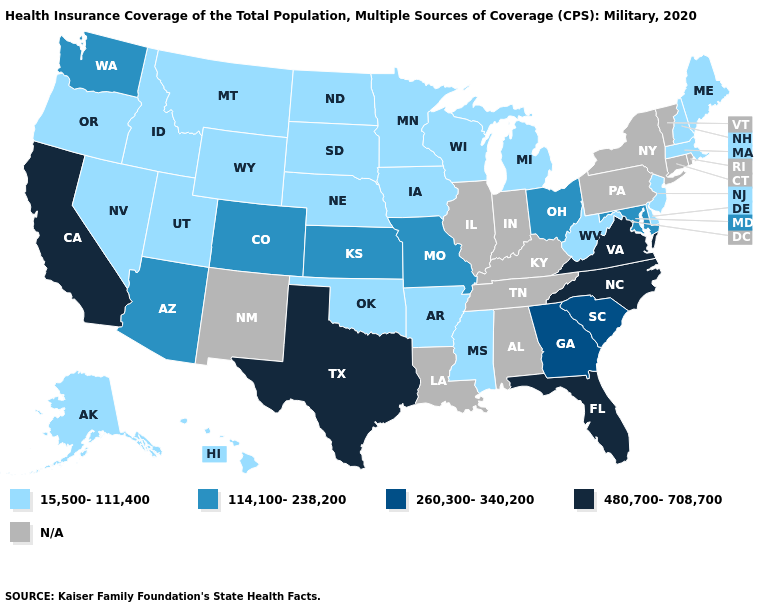Name the states that have a value in the range N/A?
Quick response, please. Alabama, Connecticut, Illinois, Indiana, Kentucky, Louisiana, New Mexico, New York, Pennsylvania, Rhode Island, Tennessee, Vermont. What is the highest value in the USA?
Quick response, please. 480,700-708,700. Does the first symbol in the legend represent the smallest category?
Answer briefly. Yes. Name the states that have a value in the range N/A?
Concise answer only. Alabama, Connecticut, Illinois, Indiana, Kentucky, Louisiana, New Mexico, New York, Pennsylvania, Rhode Island, Tennessee, Vermont. What is the lowest value in the USA?
Give a very brief answer. 15,500-111,400. Name the states that have a value in the range 260,300-340,200?
Quick response, please. Georgia, South Carolina. What is the highest value in the West ?
Answer briefly. 480,700-708,700. Which states hav the highest value in the South?
Quick response, please. Florida, North Carolina, Texas, Virginia. What is the highest value in the South ?
Concise answer only. 480,700-708,700. Does Oregon have the highest value in the West?
Answer briefly. No. What is the highest value in states that border New Hampshire?
Give a very brief answer. 15,500-111,400. 